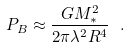<formula> <loc_0><loc_0><loc_500><loc_500>P _ { B } \approx \frac { G M _ { * } ^ { 2 } } { 2 \pi \lambda ^ { 2 } R ^ { 4 } } \ .</formula> 